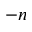Convert formula to latex. <formula><loc_0><loc_0><loc_500><loc_500>- n</formula> 